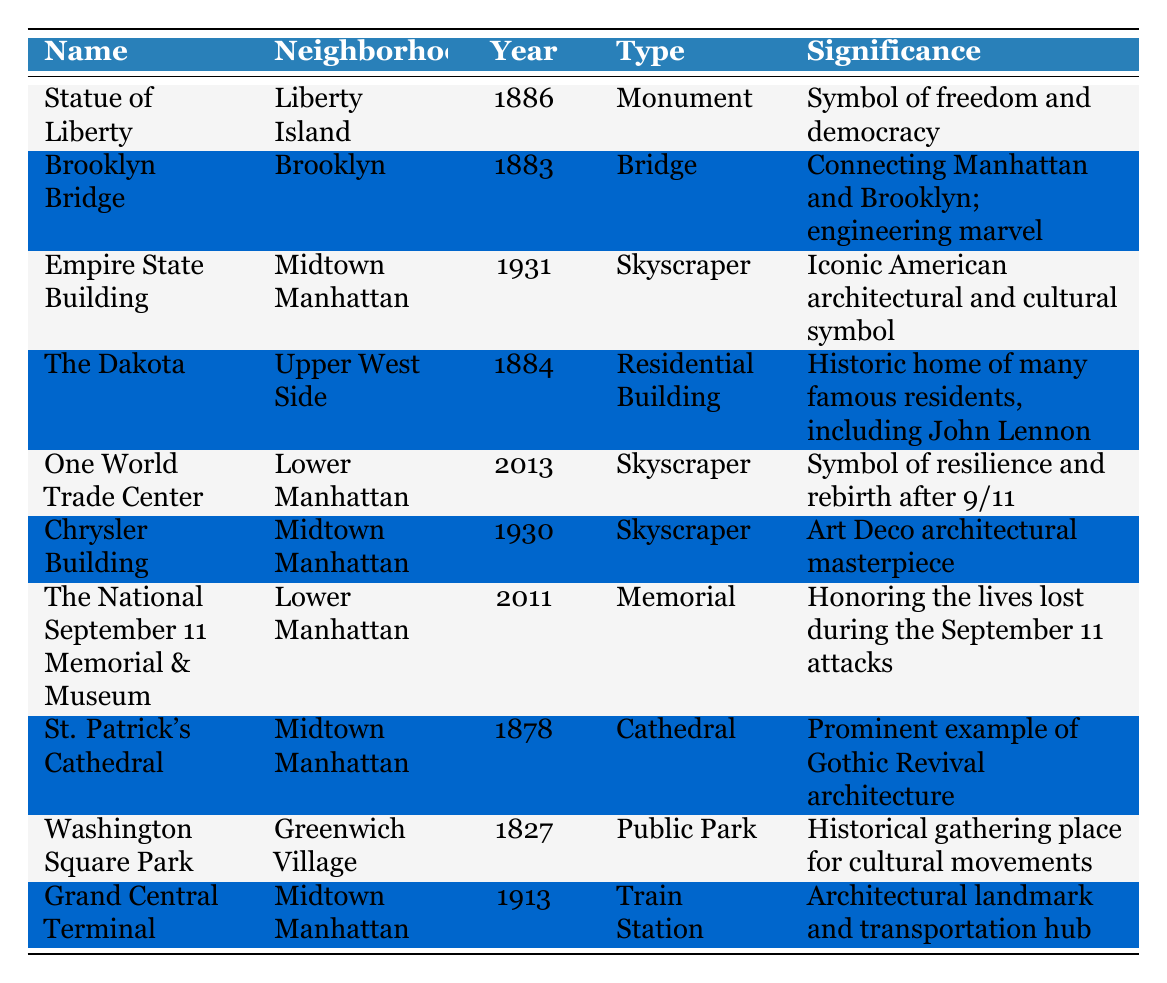What year was the Statue of Liberty established? The year established for the Statue of Liberty is directly provided in the table under the "Year" column, which is 1886.
Answer: 1886 Which landmark is a public park? By examining the "Type" column in the table, Washington Square Park is the only entry listed as "Public Park."
Answer: Washington Square Park How many landmarks were established in the 20th century or later? The relevant years for the 20th century or later are 1931 (Empire State Building), 1930 (Chrysler Building), 2011 (The National September 11 Memorial & Museum), and 2013 (One World Trade Center). There are 4 entries that fit this criterion.
Answer: 4 Is the Brooklyn Bridge a memorial? The table indicates that the Brooklyn Bridge is categorized as a "Bridge," not as a "Memorial," based on the "Type" column. Therefore, the answer is no.
Answer: No What is the significance of the Grand Central Terminal? To find the significance of the Grand Central Terminal, we refer to the "Significance" column, which states that it is an "Architectural landmark and transportation hub."
Answer: Architectural landmark and transportation hub Which neighborhood has the oldest landmark listed? The neighborhood with the oldest landmark can be determined by comparing the "Year" column. Washington Square Park was established in 1827, making it the oldest among the landmarks listed.
Answer: Greenwich Village If we consider the average year the established landmarks were built, how would we calculate this? We sum the establishment years (1886 + 1883 + 1931 + 1884 + 2013 + 1930 + 2011 + 1878 + 1827 + 1913 = 1889.2), then divide by the number of landmarks (10) to get the average year. Therefore, the average is 1889.2, round to 1890.
Answer: 1890 How many skyscrapers are listed in the table? By checking the "Type" column, there are 4 entries marked as "Skyscraper" (Empire State Building, One World Trade Center, Chrysler Building).
Answer: 4 Was St. Patrick's Cathedral established before the 20th century? The "Year" column indicates that St. Patrick's Cathedral was established in 1878, which is well before the 20th century. Therefore, the answer is yes.
Answer: Yes 